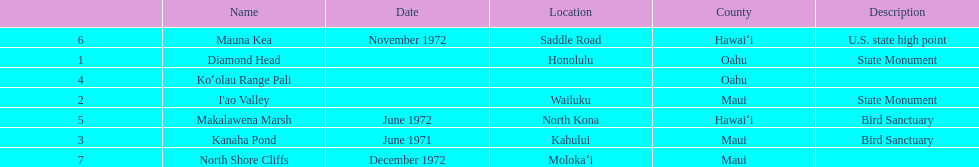What are the total number of landmarks located in maui? 3. 